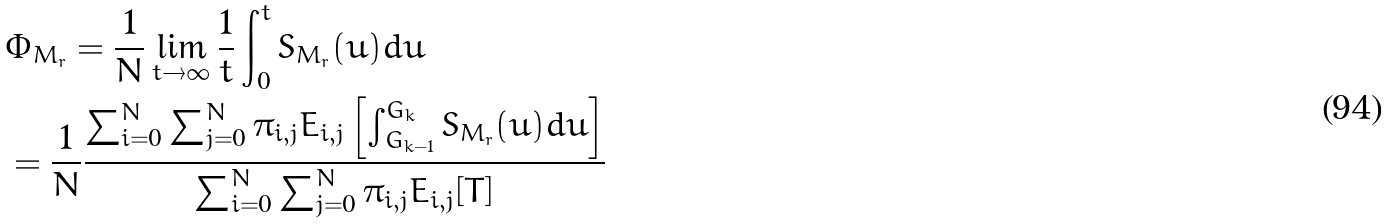Convert formula to latex. <formula><loc_0><loc_0><loc_500><loc_500>& \Phi _ { M _ { r } } = \frac { 1 } { N } \lim _ { t \to \infty } \frac { 1 } { t } \int _ { 0 } ^ { t } S _ { M _ { r } } ( u ) d u \\ & = \frac { 1 } { N } \frac { \sum _ { i = 0 } ^ { N } \sum _ { j = 0 } ^ { N } \pi _ { i , j } E _ { i , j } \left [ \int _ { G _ { k - 1 } } ^ { G _ { k } } S _ { M _ { r } } ( u ) d u \right ] } { \sum _ { i = 0 } ^ { N } \sum _ { j = 0 } ^ { N } \pi _ { i , j } E _ { i , j } [ T ] }</formula> 